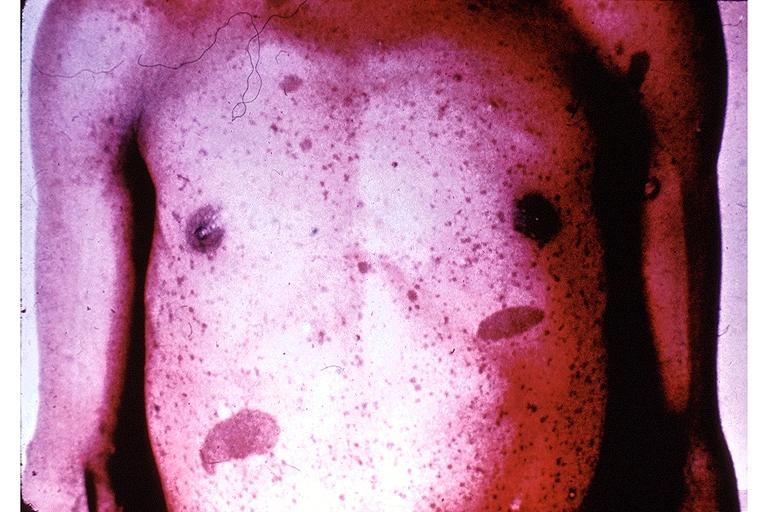does this image show neurofibromatosis-cafe-au-lait pigmentation?
Answer the question using a single word or phrase. Yes 